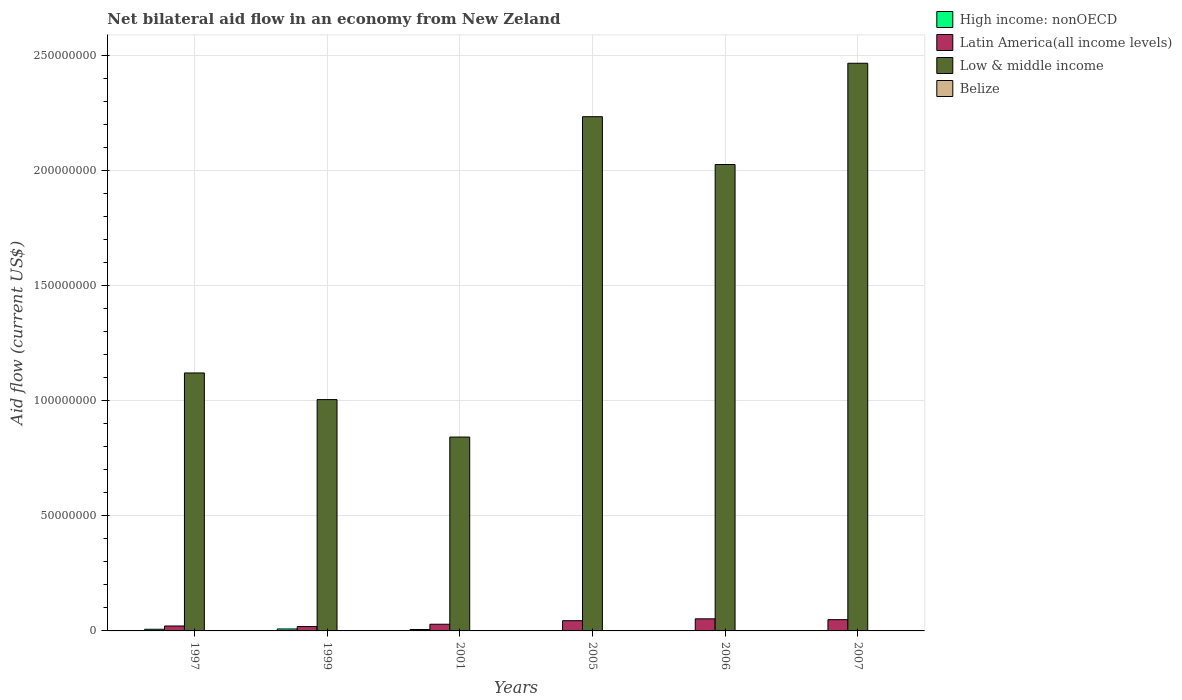Are the number of bars per tick equal to the number of legend labels?
Ensure brevity in your answer.  Yes. Are the number of bars on each tick of the X-axis equal?
Your answer should be very brief. Yes. What is the label of the 5th group of bars from the left?
Your answer should be compact. 2006. In how many cases, is the number of bars for a given year not equal to the number of legend labels?
Make the answer very short. 0. What is the net bilateral aid flow in High income: nonOECD in 1999?
Your response must be concise. 8.50e+05. Across all years, what is the maximum net bilateral aid flow in Latin America(all income levels)?
Your response must be concise. 5.25e+06. In which year was the net bilateral aid flow in High income: nonOECD minimum?
Your response must be concise. 2005. What is the total net bilateral aid flow in Low & middle income in the graph?
Give a very brief answer. 9.69e+08. What is the difference between the net bilateral aid flow in Latin America(all income levels) in 1997 and that in 2006?
Keep it short and to the point. -3.11e+06. What is the difference between the net bilateral aid flow in Latin America(all income levels) in 2005 and the net bilateral aid flow in High income: nonOECD in 2001?
Ensure brevity in your answer.  3.82e+06. What is the average net bilateral aid flow in Belize per year?
Your answer should be compact. 1.83e+04. In the year 2006, what is the difference between the net bilateral aid flow in High income: nonOECD and net bilateral aid flow in Low & middle income?
Offer a very short reply. -2.02e+08. In how many years, is the net bilateral aid flow in High income: nonOECD greater than 240000000 US$?
Provide a succinct answer. 0. What is the ratio of the net bilateral aid flow in Belize in 1999 to that in 2005?
Offer a terse response. 1. Is the net bilateral aid flow in High income: nonOECD in 1999 less than that in 2006?
Offer a terse response. No. In how many years, is the net bilateral aid flow in Low & middle income greater than the average net bilateral aid flow in Low & middle income taken over all years?
Your answer should be compact. 3. Is the sum of the net bilateral aid flow in High income: nonOECD in 1997 and 2005 greater than the maximum net bilateral aid flow in Low & middle income across all years?
Offer a terse response. No. What does the 3rd bar from the left in 2001 represents?
Provide a short and direct response. Low & middle income. How many bars are there?
Offer a terse response. 24. Does the graph contain any zero values?
Provide a short and direct response. No. How many legend labels are there?
Provide a short and direct response. 4. How are the legend labels stacked?
Your response must be concise. Vertical. What is the title of the graph?
Provide a short and direct response. Net bilateral aid flow in an economy from New Zeland. Does "Eritrea" appear as one of the legend labels in the graph?
Your response must be concise. No. What is the label or title of the X-axis?
Your response must be concise. Years. What is the Aid flow (current US$) of High income: nonOECD in 1997?
Make the answer very short. 7.20e+05. What is the Aid flow (current US$) in Latin America(all income levels) in 1997?
Ensure brevity in your answer.  2.14e+06. What is the Aid flow (current US$) of Low & middle income in 1997?
Provide a short and direct response. 1.12e+08. What is the Aid flow (current US$) in Belize in 1997?
Make the answer very short. 3.00e+04. What is the Aid flow (current US$) of High income: nonOECD in 1999?
Your response must be concise. 8.50e+05. What is the Aid flow (current US$) of Latin America(all income levels) in 1999?
Provide a succinct answer. 1.90e+06. What is the Aid flow (current US$) of Low & middle income in 1999?
Offer a terse response. 1.00e+08. What is the Aid flow (current US$) in High income: nonOECD in 2001?
Offer a terse response. 6.20e+05. What is the Aid flow (current US$) in Latin America(all income levels) in 2001?
Keep it short and to the point. 2.90e+06. What is the Aid flow (current US$) in Low & middle income in 2001?
Provide a short and direct response. 8.42e+07. What is the Aid flow (current US$) in Belize in 2001?
Ensure brevity in your answer.  10000. What is the Aid flow (current US$) in Latin America(all income levels) in 2005?
Give a very brief answer. 4.44e+06. What is the Aid flow (current US$) of Low & middle income in 2005?
Provide a short and direct response. 2.23e+08. What is the Aid flow (current US$) of High income: nonOECD in 2006?
Give a very brief answer. 1.10e+05. What is the Aid flow (current US$) of Latin America(all income levels) in 2006?
Your answer should be very brief. 5.25e+06. What is the Aid flow (current US$) of Low & middle income in 2006?
Ensure brevity in your answer.  2.02e+08. What is the Aid flow (current US$) of Belize in 2006?
Ensure brevity in your answer.  10000. What is the Aid flow (current US$) of High income: nonOECD in 2007?
Provide a short and direct response. 1.40e+05. What is the Aid flow (current US$) in Latin America(all income levels) in 2007?
Your answer should be very brief. 4.89e+06. What is the Aid flow (current US$) of Low & middle income in 2007?
Provide a short and direct response. 2.46e+08. What is the Aid flow (current US$) in Belize in 2007?
Your response must be concise. 2.00e+04. Across all years, what is the maximum Aid flow (current US$) of High income: nonOECD?
Your answer should be compact. 8.50e+05. Across all years, what is the maximum Aid flow (current US$) in Latin America(all income levels)?
Provide a short and direct response. 5.25e+06. Across all years, what is the maximum Aid flow (current US$) of Low & middle income?
Give a very brief answer. 2.46e+08. Across all years, what is the maximum Aid flow (current US$) in Belize?
Offer a terse response. 3.00e+04. Across all years, what is the minimum Aid flow (current US$) of Latin America(all income levels)?
Offer a terse response. 1.90e+06. Across all years, what is the minimum Aid flow (current US$) in Low & middle income?
Ensure brevity in your answer.  8.42e+07. What is the total Aid flow (current US$) of High income: nonOECD in the graph?
Give a very brief answer. 2.55e+06. What is the total Aid flow (current US$) of Latin America(all income levels) in the graph?
Your answer should be compact. 2.15e+07. What is the total Aid flow (current US$) of Low & middle income in the graph?
Ensure brevity in your answer.  9.69e+08. What is the difference between the Aid flow (current US$) in High income: nonOECD in 1997 and that in 1999?
Your answer should be compact. -1.30e+05. What is the difference between the Aid flow (current US$) of Low & middle income in 1997 and that in 1999?
Ensure brevity in your answer.  1.16e+07. What is the difference between the Aid flow (current US$) of Belize in 1997 and that in 1999?
Offer a very short reply. 10000. What is the difference between the Aid flow (current US$) of Latin America(all income levels) in 1997 and that in 2001?
Ensure brevity in your answer.  -7.60e+05. What is the difference between the Aid flow (current US$) of Low & middle income in 1997 and that in 2001?
Make the answer very short. 2.78e+07. What is the difference between the Aid flow (current US$) in Latin America(all income levels) in 1997 and that in 2005?
Your answer should be compact. -2.30e+06. What is the difference between the Aid flow (current US$) of Low & middle income in 1997 and that in 2005?
Your response must be concise. -1.11e+08. What is the difference between the Aid flow (current US$) of High income: nonOECD in 1997 and that in 2006?
Your response must be concise. 6.10e+05. What is the difference between the Aid flow (current US$) of Latin America(all income levels) in 1997 and that in 2006?
Your answer should be very brief. -3.11e+06. What is the difference between the Aid flow (current US$) in Low & middle income in 1997 and that in 2006?
Ensure brevity in your answer.  -9.05e+07. What is the difference between the Aid flow (current US$) in High income: nonOECD in 1997 and that in 2007?
Give a very brief answer. 5.80e+05. What is the difference between the Aid flow (current US$) in Latin America(all income levels) in 1997 and that in 2007?
Offer a terse response. -2.75e+06. What is the difference between the Aid flow (current US$) in Low & middle income in 1997 and that in 2007?
Offer a terse response. -1.34e+08. What is the difference between the Aid flow (current US$) of Latin America(all income levels) in 1999 and that in 2001?
Offer a very short reply. -1.00e+06. What is the difference between the Aid flow (current US$) in Low & middle income in 1999 and that in 2001?
Your answer should be compact. 1.63e+07. What is the difference between the Aid flow (current US$) in Belize in 1999 and that in 2001?
Offer a terse response. 10000. What is the difference between the Aid flow (current US$) in High income: nonOECD in 1999 and that in 2005?
Your response must be concise. 7.40e+05. What is the difference between the Aid flow (current US$) of Latin America(all income levels) in 1999 and that in 2005?
Make the answer very short. -2.54e+06. What is the difference between the Aid flow (current US$) in Low & middle income in 1999 and that in 2005?
Provide a succinct answer. -1.23e+08. What is the difference between the Aid flow (current US$) of High income: nonOECD in 1999 and that in 2006?
Your response must be concise. 7.40e+05. What is the difference between the Aid flow (current US$) in Latin America(all income levels) in 1999 and that in 2006?
Give a very brief answer. -3.35e+06. What is the difference between the Aid flow (current US$) in Low & middle income in 1999 and that in 2006?
Provide a short and direct response. -1.02e+08. What is the difference between the Aid flow (current US$) in Belize in 1999 and that in 2006?
Ensure brevity in your answer.  10000. What is the difference between the Aid flow (current US$) of High income: nonOECD in 1999 and that in 2007?
Keep it short and to the point. 7.10e+05. What is the difference between the Aid flow (current US$) in Latin America(all income levels) in 1999 and that in 2007?
Keep it short and to the point. -2.99e+06. What is the difference between the Aid flow (current US$) in Low & middle income in 1999 and that in 2007?
Offer a terse response. -1.46e+08. What is the difference between the Aid flow (current US$) of Belize in 1999 and that in 2007?
Your response must be concise. 0. What is the difference between the Aid flow (current US$) of High income: nonOECD in 2001 and that in 2005?
Provide a short and direct response. 5.10e+05. What is the difference between the Aid flow (current US$) in Latin America(all income levels) in 2001 and that in 2005?
Offer a terse response. -1.54e+06. What is the difference between the Aid flow (current US$) of Low & middle income in 2001 and that in 2005?
Your answer should be very brief. -1.39e+08. What is the difference between the Aid flow (current US$) in High income: nonOECD in 2001 and that in 2006?
Offer a terse response. 5.10e+05. What is the difference between the Aid flow (current US$) of Latin America(all income levels) in 2001 and that in 2006?
Keep it short and to the point. -2.35e+06. What is the difference between the Aid flow (current US$) of Low & middle income in 2001 and that in 2006?
Keep it short and to the point. -1.18e+08. What is the difference between the Aid flow (current US$) in Latin America(all income levels) in 2001 and that in 2007?
Offer a very short reply. -1.99e+06. What is the difference between the Aid flow (current US$) in Low & middle income in 2001 and that in 2007?
Provide a short and direct response. -1.62e+08. What is the difference between the Aid flow (current US$) in High income: nonOECD in 2005 and that in 2006?
Your response must be concise. 0. What is the difference between the Aid flow (current US$) in Latin America(all income levels) in 2005 and that in 2006?
Offer a very short reply. -8.10e+05. What is the difference between the Aid flow (current US$) of Low & middle income in 2005 and that in 2006?
Keep it short and to the point. 2.08e+07. What is the difference between the Aid flow (current US$) of Belize in 2005 and that in 2006?
Provide a succinct answer. 10000. What is the difference between the Aid flow (current US$) in Latin America(all income levels) in 2005 and that in 2007?
Make the answer very short. -4.50e+05. What is the difference between the Aid flow (current US$) in Low & middle income in 2005 and that in 2007?
Make the answer very short. -2.32e+07. What is the difference between the Aid flow (current US$) in High income: nonOECD in 2006 and that in 2007?
Offer a very short reply. -3.00e+04. What is the difference between the Aid flow (current US$) of Latin America(all income levels) in 2006 and that in 2007?
Keep it short and to the point. 3.60e+05. What is the difference between the Aid flow (current US$) of Low & middle income in 2006 and that in 2007?
Keep it short and to the point. -4.40e+07. What is the difference between the Aid flow (current US$) of Belize in 2006 and that in 2007?
Ensure brevity in your answer.  -10000. What is the difference between the Aid flow (current US$) of High income: nonOECD in 1997 and the Aid flow (current US$) of Latin America(all income levels) in 1999?
Give a very brief answer. -1.18e+06. What is the difference between the Aid flow (current US$) in High income: nonOECD in 1997 and the Aid flow (current US$) in Low & middle income in 1999?
Give a very brief answer. -9.97e+07. What is the difference between the Aid flow (current US$) of High income: nonOECD in 1997 and the Aid flow (current US$) of Belize in 1999?
Your response must be concise. 7.00e+05. What is the difference between the Aid flow (current US$) in Latin America(all income levels) in 1997 and the Aid flow (current US$) in Low & middle income in 1999?
Ensure brevity in your answer.  -9.83e+07. What is the difference between the Aid flow (current US$) of Latin America(all income levels) in 1997 and the Aid flow (current US$) of Belize in 1999?
Your answer should be compact. 2.12e+06. What is the difference between the Aid flow (current US$) of Low & middle income in 1997 and the Aid flow (current US$) of Belize in 1999?
Make the answer very short. 1.12e+08. What is the difference between the Aid flow (current US$) of High income: nonOECD in 1997 and the Aid flow (current US$) of Latin America(all income levels) in 2001?
Give a very brief answer. -2.18e+06. What is the difference between the Aid flow (current US$) of High income: nonOECD in 1997 and the Aid flow (current US$) of Low & middle income in 2001?
Your answer should be compact. -8.34e+07. What is the difference between the Aid flow (current US$) of High income: nonOECD in 1997 and the Aid flow (current US$) of Belize in 2001?
Your answer should be compact. 7.10e+05. What is the difference between the Aid flow (current US$) in Latin America(all income levels) in 1997 and the Aid flow (current US$) in Low & middle income in 2001?
Your answer should be very brief. -8.20e+07. What is the difference between the Aid flow (current US$) in Latin America(all income levels) in 1997 and the Aid flow (current US$) in Belize in 2001?
Offer a very short reply. 2.13e+06. What is the difference between the Aid flow (current US$) of Low & middle income in 1997 and the Aid flow (current US$) of Belize in 2001?
Make the answer very short. 1.12e+08. What is the difference between the Aid flow (current US$) of High income: nonOECD in 1997 and the Aid flow (current US$) of Latin America(all income levels) in 2005?
Your answer should be compact. -3.72e+06. What is the difference between the Aid flow (current US$) in High income: nonOECD in 1997 and the Aid flow (current US$) in Low & middle income in 2005?
Give a very brief answer. -2.23e+08. What is the difference between the Aid flow (current US$) in High income: nonOECD in 1997 and the Aid flow (current US$) in Belize in 2005?
Your answer should be compact. 7.00e+05. What is the difference between the Aid flow (current US$) of Latin America(all income levels) in 1997 and the Aid flow (current US$) of Low & middle income in 2005?
Ensure brevity in your answer.  -2.21e+08. What is the difference between the Aid flow (current US$) in Latin America(all income levels) in 1997 and the Aid flow (current US$) in Belize in 2005?
Make the answer very short. 2.12e+06. What is the difference between the Aid flow (current US$) of Low & middle income in 1997 and the Aid flow (current US$) of Belize in 2005?
Offer a very short reply. 1.12e+08. What is the difference between the Aid flow (current US$) in High income: nonOECD in 1997 and the Aid flow (current US$) in Latin America(all income levels) in 2006?
Your response must be concise. -4.53e+06. What is the difference between the Aid flow (current US$) in High income: nonOECD in 1997 and the Aid flow (current US$) in Low & middle income in 2006?
Offer a terse response. -2.02e+08. What is the difference between the Aid flow (current US$) of High income: nonOECD in 1997 and the Aid flow (current US$) of Belize in 2006?
Your answer should be compact. 7.10e+05. What is the difference between the Aid flow (current US$) in Latin America(all income levels) in 1997 and the Aid flow (current US$) in Low & middle income in 2006?
Give a very brief answer. -2.00e+08. What is the difference between the Aid flow (current US$) in Latin America(all income levels) in 1997 and the Aid flow (current US$) in Belize in 2006?
Provide a short and direct response. 2.13e+06. What is the difference between the Aid flow (current US$) of Low & middle income in 1997 and the Aid flow (current US$) of Belize in 2006?
Offer a very short reply. 1.12e+08. What is the difference between the Aid flow (current US$) of High income: nonOECD in 1997 and the Aid flow (current US$) of Latin America(all income levels) in 2007?
Provide a succinct answer. -4.17e+06. What is the difference between the Aid flow (current US$) in High income: nonOECD in 1997 and the Aid flow (current US$) in Low & middle income in 2007?
Keep it short and to the point. -2.46e+08. What is the difference between the Aid flow (current US$) in High income: nonOECD in 1997 and the Aid flow (current US$) in Belize in 2007?
Your answer should be very brief. 7.00e+05. What is the difference between the Aid flow (current US$) in Latin America(all income levels) in 1997 and the Aid flow (current US$) in Low & middle income in 2007?
Ensure brevity in your answer.  -2.44e+08. What is the difference between the Aid flow (current US$) of Latin America(all income levels) in 1997 and the Aid flow (current US$) of Belize in 2007?
Give a very brief answer. 2.12e+06. What is the difference between the Aid flow (current US$) of Low & middle income in 1997 and the Aid flow (current US$) of Belize in 2007?
Keep it short and to the point. 1.12e+08. What is the difference between the Aid flow (current US$) in High income: nonOECD in 1999 and the Aid flow (current US$) in Latin America(all income levels) in 2001?
Make the answer very short. -2.05e+06. What is the difference between the Aid flow (current US$) of High income: nonOECD in 1999 and the Aid flow (current US$) of Low & middle income in 2001?
Your response must be concise. -8.33e+07. What is the difference between the Aid flow (current US$) of High income: nonOECD in 1999 and the Aid flow (current US$) of Belize in 2001?
Your answer should be compact. 8.40e+05. What is the difference between the Aid flow (current US$) in Latin America(all income levels) in 1999 and the Aid flow (current US$) in Low & middle income in 2001?
Your response must be concise. -8.23e+07. What is the difference between the Aid flow (current US$) in Latin America(all income levels) in 1999 and the Aid flow (current US$) in Belize in 2001?
Ensure brevity in your answer.  1.89e+06. What is the difference between the Aid flow (current US$) in Low & middle income in 1999 and the Aid flow (current US$) in Belize in 2001?
Offer a terse response. 1.00e+08. What is the difference between the Aid flow (current US$) of High income: nonOECD in 1999 and the Aid flow (current US$) of Latin America(all income levels) in 2005?
Your answer should be compact. -3.59e+06. What is the difference between the Aid flow (current US$) in High income: nonOECD in 1999 and the Aid flow (current US$) in Low & middle income in 2005?
Offer a terse response. -2.22e+08. What is the difference between the Aid flow (current US$) of High income: nonOECD in 1999 and the Aid flow (current US$) of Belize in 2005?
Make the answer very short. 8.30e+05. What is the difference between the Aid flow (current US$) in Latin America(all income levels) in 1999 and the Aid flow (current US$) in Low & middle income in 2005?
Your response must be concise. -2.21e+08. What is the difference between the Aid flow (current US$) in Latin America(all income levels) in 1999 and the Aid flow (current US$) in Belize in 2005?
Your answer should be very brief. 1.88e+06. What is the difference between the Aid flow (current US$) of Low & middle income in 1999 and the Aid flow (current US$) of Belize in 2005?
Your response must be concise. 1.00e+08. What is the difference between the Aid flow (current US$) of High income: nonOECD in 1999 and the Aid flow (current US$) of Latin America(all income levels) in 2006?
Your answer should be compact. -4.40e+06. What is the difference between the Aid flow (current US$) of High income: nonOECD in 1999 and the Aid flow (current US$) of Low & middle income in 2006?
Give a very brief answer. -2.02e+08. What is the difference between the Aid flow (current US$) of High income: nonOECD in 1999 and the Aid flow (current US$) of Belize in 2006?
Your response must be concise. 8.40e+05. What is the difference between the Aid flow (current US$) of Latin America(all income levels) in 1999 and the Aid flow (current US$) of Low & middle income in 2006?
Offer a terse response. -2.01e+08. What is the difference between the Aid flow (current US$) in Latin America(all income levels) in 1999 and the Aid flow (current US$) in Belize in 2006?
Your answer should be very brief. 1.89e+06. What is the difference between the Aid flow (current US$) in Low & middle income in 1999 and the Aid flow (current US$) in Belize in 2006?
Keep it short and to the point. 1.00e+08. What is the difference between the Aid flow (current US$) of High income: nonOECD in 1999 and the Aid flow (current US$) of Latin America(all income levels) in 2007?
Make the answer very short. -4.04e+06. What is the difference between the Aid flow (current US$) in High income: nonOECD in 1999 and the Aid flow (current US$) in Low & middle income in 2007?
Provide a short and direct response. -2.46e+08. What is the difference between the Aid flow (current US$) in High income: nonOECD in 1999 and the Aid flow (current US$) in Belize in 2007?
Your response must be concise. 8.30e+05. What is the difference between the Aid flow (current US$) of Latin America(all income levels) in 1999 and the Aid flow (current US$) of Low & middle income in 2007?
Ensure brevity in your answer.  -2.45e+08. What is the difference between the Aid flow (current US$) of Latin America(all income levels) in 1999 and the Aid flow (current US$) of Belize in 2007?
Ensure brevity in your answer.  1.88e+06. What is the difference between the Aid flow (current US$) in Low & middle income in 1999 and the Aid flow (current US$) in Belize in 2007?
Your answer should be compact. 1.00e+08. What is the difference between the Aid flow (current US$) in High income: nonOECD in 2001 and the Aid flow (current US$) in Latin America(all income levels) in 2005?
Make the answer very short. -3.82e+06. What is the difference between the Aid flow (current US$) in High income: nonOECD in 2001 and the Aid flow (current US$) in Low & middle income in 2005?
Your answer should be very brief. -2.23e+08. What is the difference between the Aid flow (current US$) in Latin America(all income levels) in 2001 and the Aid flow (current US$) in Low & middle income in 2005?
Ensure brevity in your answer.  -2.20e+08. What is the difference between the Aid flow (current US$) in Latin America(all income levels) in 2001 and the Aid flow (current US$) in Belize in 2005?
Your response must be concise. 2.88e+06. What is the difference between the Aid flow (current US$) of Low & middle income in 2001 and the Aid flow (current US$) of Belize in 2005?
Provide a short and direct response. 8.42e+07. What is the difference between the Aid flow (current US$) of High income: nonOECD in 2001 and the Aid flow (current US$) of Latin America(all income levels) in 2006?
Your response must be concise. -4.63e+06. What is the difference between the Aid flow (current US$) of High income: nonOECD in 2001 and the Aid flow (current US$) of Low & middle income in 2006?
Keep it short and to the point. -2.02e+08. What is the difference between the Aid flow (current US$) of Latin America(all income levels) in 2001 and the Aid flow (current US$) of Low & middle income in 2006?
Offer a very short reply. -2.00e+08. What is the difference between the Aid flow (current US$) of Latin America(all income levels) in 2001 and the Aid flow (current US$) of Belize in 2006?
Offer a terse response. 2.89e+06. What is the difference between the Aid flow (current US$) of Low & middle income in 2001 and the Aid flow (current US$) of Belize in 2006?
Ensure brevity in your answer.  8.42e+07. What is the difference between the Aid flow (current US$) of High income: nonOECD in 2001 and the Aid flow (current US$) of Latin America(all income levels) in 2007?
Your answer should be compact. -4.27e+06. What is the difference between the Aid flow (current US$) of High income: nonOECD in 2001 and the Aid flow (current US$) of Low & middle income in 2007?
Your response must be concise. -2.46e+08. What is the difference between the Aid flow (current US$) of High income: nonOECD in 2001 and the Aid flow (current US$) of Belize in 2007?
Provide a short and direct response. 6.00e+05. What is the difference between the Aid flow (current US$) in Latin America(all income levels) in 2001 and the Aid flow (current US$) in Low & middle income in 2007?
Give a very brief answer. -2.44e+08. What is the difference between the Aid flow (current US$) in Latin America(all income levels) in 2001 and the Aid flow (current US$) in Belize in 2007?
Your response must be concise. 2.88e+06. What is the difference between the Aid flow (current US$) of Low & middle income in 2001 and the Aid flow (current US$) of Belize in 2007?
Your answer should be very brief. 8.42e+07. What is the difference between the Aid flow (current US$) in High income: nonOECD in 2005 and the Aid flow (current US$) in Latin America(all income levels) in 2006?
Offer a terse response. -5.14e+06. What is the difference between the Aid flow (current US$) in High income: nonOECD in 2005 and the Aid flow (current US$) in Low & middle income in 2006?
Your answer should be compact. -2.02e+08. What is the difference between the Aid flow (current US$) of Latin America(all income levels) in 2005 and the Aid flow (current US$) of Low & middle income in 2006?
Your response must be concise. -1.98e+08. What is the difference between the Aid flow (current US$) of Latin America(all income levels) in 2005 and the Aid flow (current US$) of Belize in 2006?
Your answer should be very brief. 4.43e+06. What is the difference between the Aid flow (current US$) in Low & middle income in 2005 and the Aid flow (current US$) in Belize in 2006?
Your response must be concise. 2.23e+08. What is the difference between the Aid flow (current US$) of High income: nonOECD in 2005 and the Aid flow (current US$) of Latin America(all income levels) in 2007?
Keep it short and to the point. -4.78e+06. What is the difference between the Aid flow (current US$) of High income: nonOECD in 2005 and the Aid flow (current US$) of Low & middle income in 2007?
Keep it short and to the point. -2.46e+08. What is the difference between the Aid flow (current US$) in High income: nonOECD in 2005 and the Aid flow (current US$) in Belize in 2007?
Give a very brief answer. 9.00e+04. What is the difference between the Aid flow (current US$) in Latin America(all income levels) in 2005 and the Aid flow (current US$) in Low & middle income in 2007?
Offer a terse response. -2.42e+08. What is the difference between the Aid flow (current US$) of Latin America(all income levels) in 2005 and the Aid flow (current US$) of Belize in 2007?
Keep it short and to the point. 4.42e+06. What is the difference between the Aid flow (current US$) in Low & middle income in 2005 and the Aid flow (current US$) in Belize in 2007?
Make the answer very short. 2.23e+08. What is the difference between the Aid flow (current US$) in High income: nonOECD in 2006 and the Aid flow (current US$) in Latin America(all income levels) in 2007?
Offer a very short reply. -4.78e+06. What is the difference between the Aid flow (current US$) in High income: nonOECD in 2006 and the Aid flow (current US$) in Low & middle income in 2007?
Make the answer very short. -2.46e+08. What is the difference between the Aid flow (current US$) in Latin America(all income levels) in 2006 and the Aid flow (current US$) in Low & middle income in 2007?
Provide a short and direct response. -2.41e+08. What is the difference between the Aid flow (current US$) of Latin America(all income levels) in 2006 and the Aid flow (current US$) of Belize in 2007?
Your answer should be compact. 5.23e+06. What is the difference between the Aid flow (current US$) in Low & middle income in 2006 and the Aid flow (current US$) in Belize in 2007?
Keep it short and to the point. 2.02e+08. What is the average Aid flow (current US$) of High income: nonOECD per year?
Ensure brevity in your answer.  4.25e+05. What is the average Aid flow (current US$) of Latin America(all income levels) per year?
Provide a short and direct response. 3.59e+06. What is the average Aid flow (current US$) of Low & middle income per year?
Keep it short and to the point. 1.61e+08. What is the average Aid flow (current US$) in Belize per year?
Provide a short and direct response. 1.83e+04. In the year 1997, what is the difference between the Aid flow (current US$) of High income: nonOECD and Aid flow (current US$) of Latin America(all income levels)?
Your response must be concise. -1.42e+06. In the year 1997, what is the difference between the Aid flow (current US$) in High income: nonOECD and Aid flow (current US$) in Low & middle income?
Make the answer very short. -1.11e+08. In the year 1997, what is the difference between the Aid flow (current US$) of High income: nonOECD and Aid flow (current US$) of Belize?
Offer a very short reply. 6.90e+05. In the year 1997, what is the difference between the Aid flow (current US$) of Latin America(all income levels) and Aid flow (current US$) of Low & middle income?
Your answer should be compact. -1.10e+08. In the year 1997, what is the difference between the Aid flow (current US$) in Latin America(all income levels) and Aid flow (current US$) in Belize?
Your response must be concise. 2.11e+06. In the year 1997, what is the difference between the Aid flow (current US$) of Low & middle income and Aid flow (current US$) of Belize?
Offer a very short reply. 1.12e+08. In the year 1999, what is the difference between the Aid flow (current US$) of High income: nonOECD and Aid flow (current US$) of Latin America(all income levels)?
Your answer should be compact. -1.05e+06. In the year 1999, what is the difference between the Aid flow (current US$) in High income: nonOECD and Aid flow (current US$) in Low & middle income?
Offer a very short reply. -9.96e+07. In the year 1999, what is the difference between the Aid flow (current US$) of High income: nonOECD and Aid flow (current US$) of Belize?
Keep it short and to the point. 8.30e+05. In the year 1999, what is the difference between the Aid flow (current US$) of Latin America(all income levels) and Aid flow (current US$) of Low & middle income?
Ensure brevity in your answer.  -9.85e+07. In the year 1999, what is the difference between the Aid flow (current US$) of Latin America(all income levels) and Aid flow (current US$) of Belize?
Your answer should be very brief. 1.88e+06. In the year 1999, what is the difference between the Aid flow (current US$) of Low & middle income and Aid flow (current US$) of Belize?
Give a very brief answer. 1.00e+08. In the year 2001, what is the difference between the Aid flow (current US$) of High income: nonOECD and Aid flow (current US$) of Latin America(all income levels)?
Make the answer very short. -2.28e+06. In the year 2001, what is the difference between the Aid flow (current US$) of High income: nonOECD and Aid flow (current US$) of Low & middle income?
Give a very brief answer. -8.36e+07. In the year 2001, what is the difference between the Aid flow (current US$) in Latin America(all income levels) and Aid flow (current US$) in Low & middle income?
Provide a succinct answer. -8.13e+07. In the year 2001, what is the difference between the Aid flow (current US$) of Latin America(all income levels) and Aid flow (current US$) of Belize?
Give a very brief answer. 2.89e+06. In the year 2001, what is the difference between the Aid flow (current US$) of Low & middle income and Aid flow (current US$) of Belize?
Your answer should be very brief. 8.42e+07. In the year 2005, what is the difference between the Aid flow (current US$) of High income: nonOECD and Aid flow (current US$) of Latin America(all income levels)?
Give a very brief answer. -4.33e+06. In the year 2005, what is the difference between the Aid flow (current US$) in High income: nonOECD and Aid flow (current US$) in Low & middle income?
Your answer should be compact. -2.23e+08. In the year 2005, what is the difference between the Aid flow (current US$) in High income: nonOECD and Aid flow (current US$) in Belize?
Provide a short and direct response. 9.00e+04. In the year 2005, what is the difference between the Aid flow (current US$) in Latin America(all income levels) and Aid flow (current US$) in Low & middle income?
Give a very brief answer. -2.19e+08. In the year 2005, what is the difference between the Aid flow (current US$) of Latin America(all income levels) and Aid flow (current US$) of Belize?
Give a very brief answer. 4.42e+06. In the year 2005, what is the difference between the Aid flow (current US$) in Low & middle income and Aid flow (current US$) in Belize?
Keep it short and to the point. 2.23e+08. In the year 2006, what is the difference between the Aid flow (current US$) of High income: nonOECD and Aid flow (current US$) of Latin America(all income levels)?
Keep it short and to the point. -5.14e+06. In the year 2006, what is the difference between the Aid flow (current US$) in High income: nonOECD and Aid flow (current US$) in Low & middle income?
Provide a short and direct response. -2.02e+08. In the year 2006, what is the difference between the Aid flow (current US$) of Latin America(all income levels) and Aid flow (current US$) of Low & middle income?
Offer a very short reply. -1.97e+08. In the year 2006, what is the difference between the Aid flow (current US$) in Latin America(all income levels) and Aid flow (current US$) in Belize?
Offer a very short reply. 5.24e+06. In the year 2006, what is the difference between the Aid flow (current US$) of Low & middle income and Aid flow (current US$) of Belize?
Provide a short and direct response. 2.02e+08. In the year 2007, what is the difference between the Aid flow (current US$) in High income: nonOECD and Aid flow (current US$) in Latin America(all income levels)?
Your answer should be very brief. -4.75e+06. In the year 2007, what is the difference between the Aid flow (current US$) in High income: nonOECD and Aid flow (current US$) in Low & middle income?
Give a very brief answer. -2.46e+08. In the year 2007, what is the difference between the Aid flow (current US$) of High income: nonOECD and Aid flow (current US$) of Belize?
Offer a very short reply. 1.20e+05. In the year 2007, what is the difference between the Aid flow (current US$) in Latin America(all income levels) and Aid flow (current US$) in Low & middle income?
Your response must be concise. -2.42e+08. In the year 2007, what is the difference between the Aid flow (current US$) of Latin America(all income levels) and Aid flow (current US$) of Belize?
Give a very brief answer. 4.87e+06. In the year 2007, what is the difference between the Aid flow (current US$) in Low & middle income and Aid flow (current US$) in Belize?
Keep it short and to the point. 2.46e+08. What is the ratio of the Aid flow (current US$) in High income: nonOECD in 1997 to that in 1999?
Offer a very short reply. 0.85. What is the ratio of the Aid flow (current US$) in Latin America(all income levels) in 1997 to that in 1999?
Provide a short and direct response. 1.13. What is the ratio of the Aid flow (current US$) in Low & middle income in 1997 to that in 1999?
Offer a terse response. 1.12. What is the ratio of the Aid flow (current US$) in High income: nonOECD in 1997 to that in 2001?
Your response must be concise. 1.16. What is the ratio of the Aid flow (current US$) of Latin America(all income levels) in 1997 to that in 2001?
Keep it short and to the point. 0.74. What is the ratio of the Aid flow (current US$) in Low & middle income in 1997 to that in 2001?
Give a very brief answer. 1.33. What is the ratio of the Aid flow (current US$) in Belize in 1997 to that in 2001?
Provide a succinct answer. 3. What is the ratio of the Aid flow (current US$) in High income: nonOECD in 1997 to that in 2005?
Give a very brief answer. 6.55. What is the ratio of the Aid flow (current US$) in Latin America(all income levels) in 1997 to that in 2005?
Ensure brevity in your answer.  0.48. What is the ratio of the Aid flow (current US$) in Low & middle income in 1997 to that in 2005?
Your answer should be very brief. 0.5. What is the ratio of the Aid flow (current US$) of Belize in 1997 to that in 2005?
Offer a terse response. 1.5. What is the ratio of the Aid flow (current US$) of High income: nonOECD in 1997 to that in 2006?
Provide a succinct answer. 6.55. What is the ratio of the Aid flow (current US$) of Latin America(all income levels) in 1997 to that in 2006?
Your answer should be very brief. 0.41. What is the ratio of the Aid flow (current US$) in Low & middle income in 1997 to that in 2006?
Ensure brevity in your answer.  0.55. What is the ratio of the Aid flow (current US$) of High income: nonOECD in 1997 to that in 2007?
Your response must be concise. 5.14. What is the ratio of the Aid flow (current US$) in Latin America(all income levels) in 1997 to that in 2007?
Your answer should be very brief. 0.44. What is the ratio of the Aid flow (current US$) in Low & middle income in 1997 to that in 2007?
Your answer should be compact. 0.45. What is the ratio of the Aid flow (current US$) in High income: nonOECD in 1999 to that in 2001?
Keep it short and to the point. 1.37. What is the ratio of the Aid flow (current US$) in Latin America(all income levels) in 1999 to that in 2001?
Give a very brief answer. 0.66. What is the ratio of the Aid flow (current US$) of Low & middle income in 1999 to that in 2001?
Your answer should be very brief. 1.19. What is the ratio of the Aid flow (current US$) in Belize in 1999 to that in 2001?
Your answer should be compact. 2. What is the ratio of the Aid flow (current US$) of High income: nonOECD in 1999 to that in 2005?
Provide a short and direct response. 7.73. What is the ratio of the Aid flow (current US$) of Latin America(all income levels) in 1999 to that in 2005?
Give a very brief answer. 0.43. What is the ratio of the Aid flow (current US$) in Low & middle income in 1999 to that in 2005?
Give a very brief answer. 0.45. What is the ratio of the Aid flow (current US$) of Belize in 1999 to that in 2005?
Offer a very short reply. 1. What is the ratio of the Aid flow (current US$) in High income: nonOECD in 1999 to that in 2006?
Your answer should be compact. 7.73. What is the ratio of the Aid flow (current US$) of Latin America(all income levels) in 1999 to that in 2006?
Offer a terse response. 0.36. What is the ratio of the Aid flow (current US$) of Low & middle income in 1999 to that in 2006?
Offer a very short reply. 0.5. What is the ratio of the Aid flow (current US$) in High income: nonOECD in 1999 to that in 2007?
Ensure brevity in your answer.  6.07. What is the ratio of the Aid flow (current US$) of Latin America(all income levels) in 1999 to that in 2007?
Ensure brevity in your answer.  0.39. What is the ratio of the Aid flow (current US$) of Low & middle income in 1999 to that in 2007?
Your answer should be very brief. 0.41. What is the ratio of the Aid flow (current US$) in High income: nonOECD in 2001 to that in 2005?
Your answer should be compact. 5.64. What is the ratio of the Aid flow (current US$) of Latin America(all income levels) in 2001 to that in 2005?
Provide a short and direct response. 0.65. What is the ratio of the Aid flow (current US$) in Low & middle income in 2001 to that in 2005?
Keep it short and to the point. 0.38. What is the ratio of the Aid flow (current US$) in Belize in 2001 to that in 2005?
Offer a terse response. 0.5. What is the ratio of the Aid flow (current US$) of High income: nonOECD in 2001 to that in 2006?
Offer a terse response. 5.64. What is the ratio of the Aid flow (current US$) of Latin America(all income levels) in 2001 to that in 2006?
Your response must be concise. 0.55. What is the ratio of the Aid flow (current US$) of Low & middle income in 2001 to that in 2006?
Give a very brief answer. 0.42. What is the ratio of the Aid flow (current US$) in High income: nonOECD in 2001 to that in 2007?
Give a very brief answer. 4.43. What is the ratio of the Aid flow (current US$) of Latin America(all income levels) in 2001 to that in 2007?
Give a very brief answer. 0.59. What is the ratio of the Aid flow (current US$) in Low & middle income in 2001 to that in 2007?
Your response must be concise. 0.34. What is the ratio of the Aid flow (current US$) in Latin America(all income levels) in 2005 to that in 2006?
Offer a terse response. 0.85. What is the ratio of the Aid flow (current US$) in Low & middle income in 2005 to that in 2006?
Offer a terse response. 1.1. What is the ratio of the Aid flow (current US$) of High income: nonOECD in 2005 to that in 2007?
Your answer should be very brief. 0.79. What is the ratio of the Aid flow (current US$) in Latin America(all income levels) in 2005 to that in 2007?
Your answer should be compact. 0.91. What is the ratio of the Aid flow (current US$) of Low & middle income in 2005 to that in 2007?
Provide a short and direct response. 0.91. What is the ratio of the Aid flow (current US$) in High income: nonOECD in 2006 to that in 2007?
Give a very brief answer. 0.79. What is the ratio of the Aid flow (current US$) in Latin America(all income levels) in 2006 to that in 2007?
Your response must be concise. 1.07. What is the ratio of the Aid flow (current US$) of Low & middle income in 2006 to that in 2007?
Provide a succinct answer. 0.82. What is the difference between the highest and the second highest Aid flow (current US$) in High income: nonOECD?
Provide a succinct answer. 1.30e+05. What is the difference between the highest and the second highest Aid flow (current US$) of Low & middle income?
Your answer should be very brief. 2.32e+07. What is the difference between the highest and the second highest Aid flow (current US$) in Belize?
Keep it short and to the point. 10000. What is the difference between the highest and the lowest Aid flow (current US$) of High income: nonOECD?
Make the answer very short. 7.40e+05. What is the difference between the highest and the lowest Aid flow (current US$) of Latin America(all income levels)?
Ensure brevity in your answer.  3.35e+06. What is the difference between the highest and the lowest Aid flow (current US$) in Low & middle income?
Offer a very short reply. 1.62e+08. 